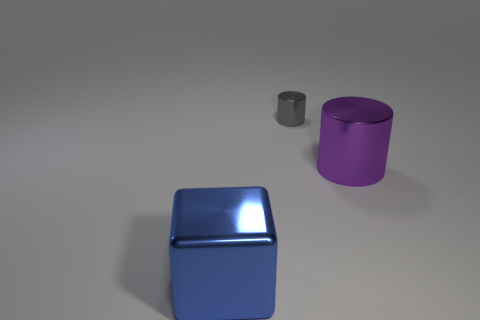Subtract 2 cylinders. How many cylinders are left? 0 Add 2 big blue rubber spheres. How many objects exist? 5 Subtract all purple cylinders. How many cylinders are left? 1 Subtract all cubes. How many objects are left? 2 Subtract 0 yellow balls. How many objects are left? 3 Subtract all purple blocks. Subtract all blue cylinders. How many blocks are left? 1 Subtract all gray spheres. How many purple cylinders are left? 1 Subtract all blue objects. Subtract all big blue shiny objects. How many objects are left? 1 Add 2 large metallic cubes. How many large metallic cubes are left? 3 Add 1 shiny cubes. How many shiny cubes exist? 2 